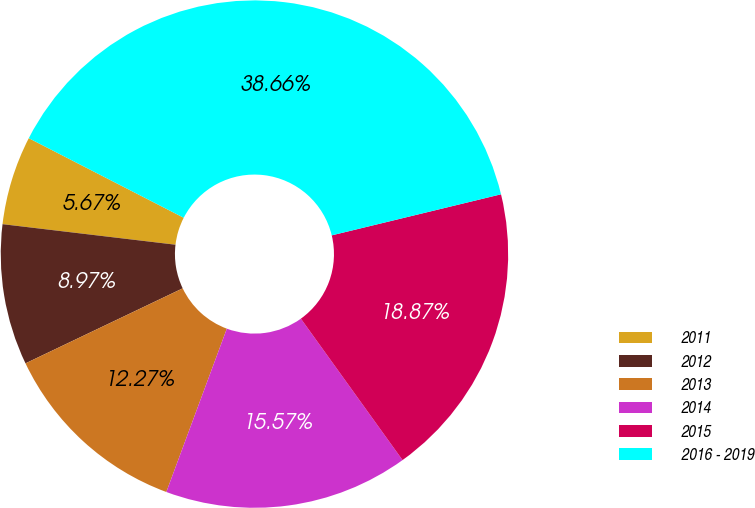Convert chart to OTSL. <chart><loc_0><loc_0><loc_500><loc_500><pie_chart><fcel>2011<fcel>2012<fcel>2013<fcel>2014<fcel>2015<fcel>2016 - 2019<nl><fcel>5.67%<fcel>8.97%<fcel>12.27%<fcel>15.57%<fcel>18.87%<fcel>38.67%<nl></chart> 